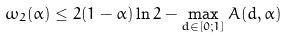<formula> <loc_0><loc_0><loc_500><loc_500>\omega _ { 2 } ( \alpha ) \leq 2 ( 1 - \alpha ) \ln 2 - \max _ { d \in [ 0 ; 1 ] } A ( d , \alpha )</formula> 